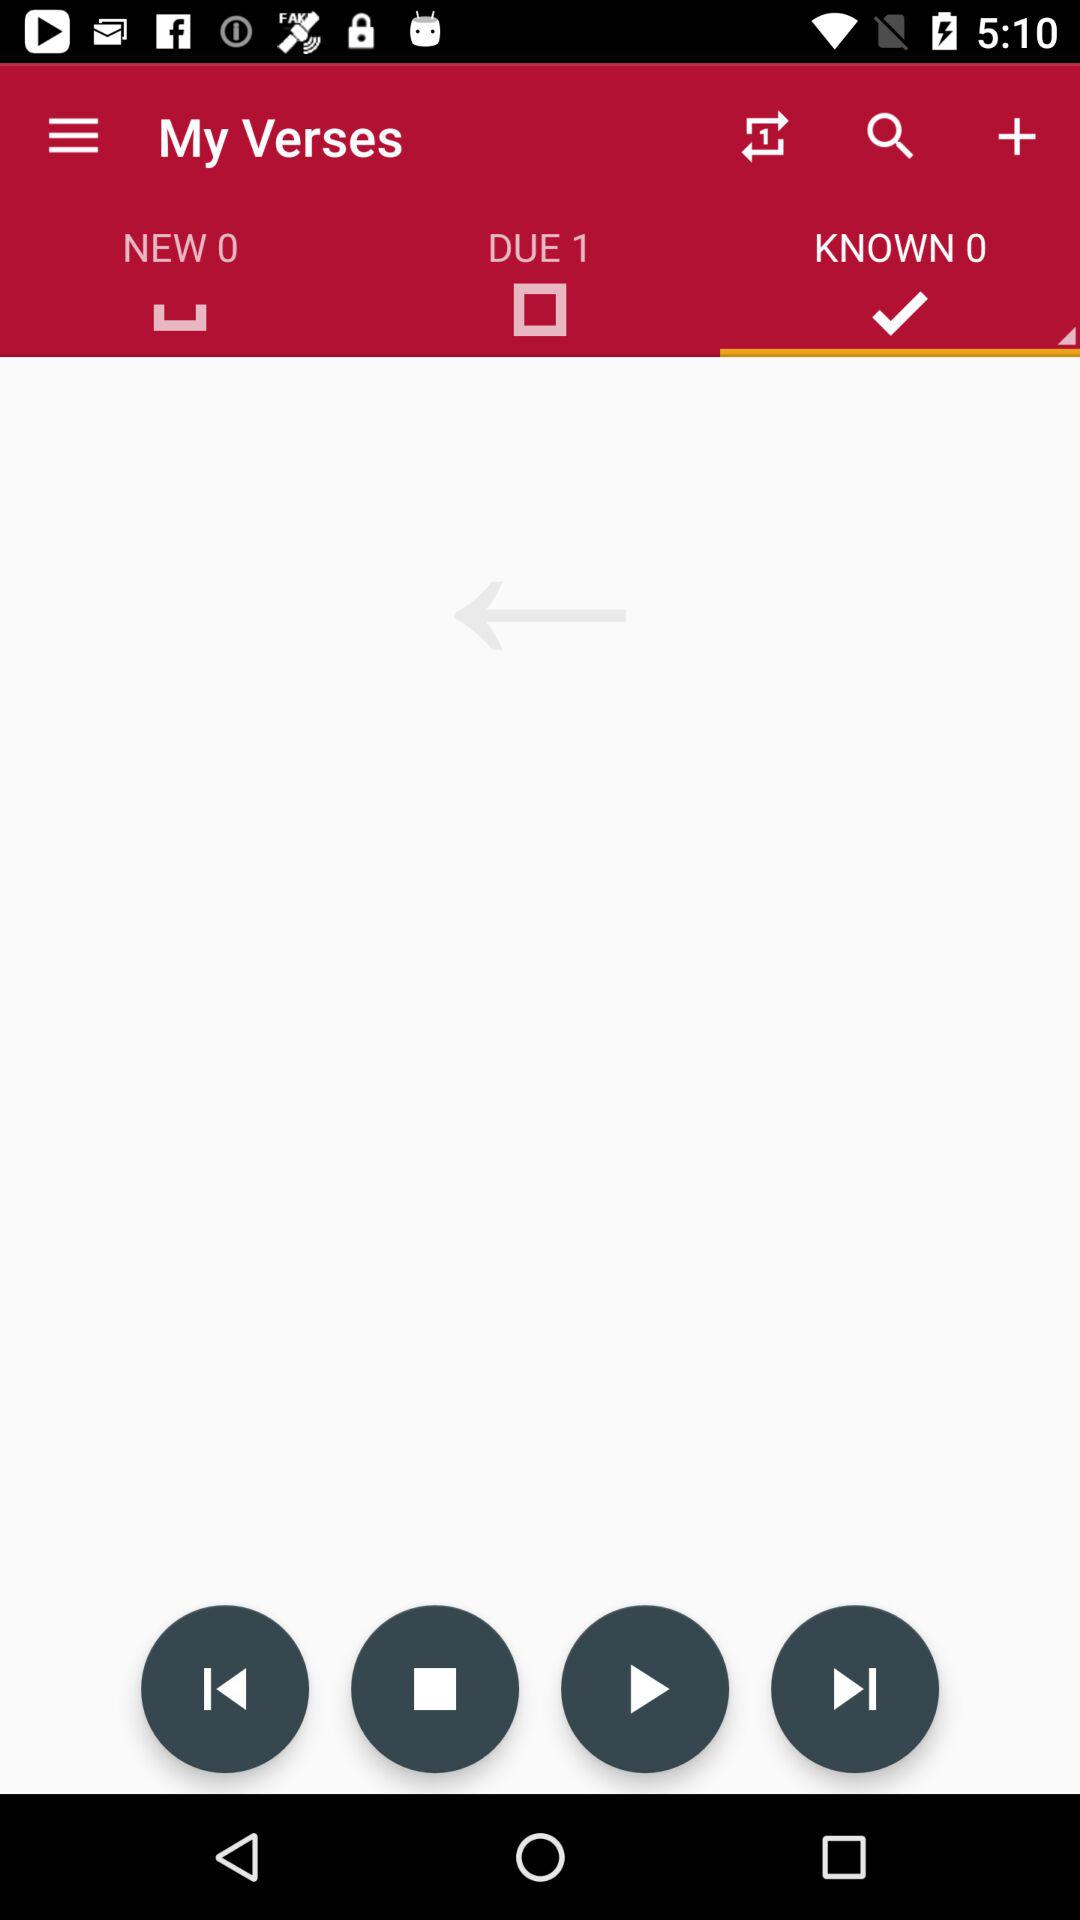What is the selected tab? The selected tab is "KNOWN 0". 